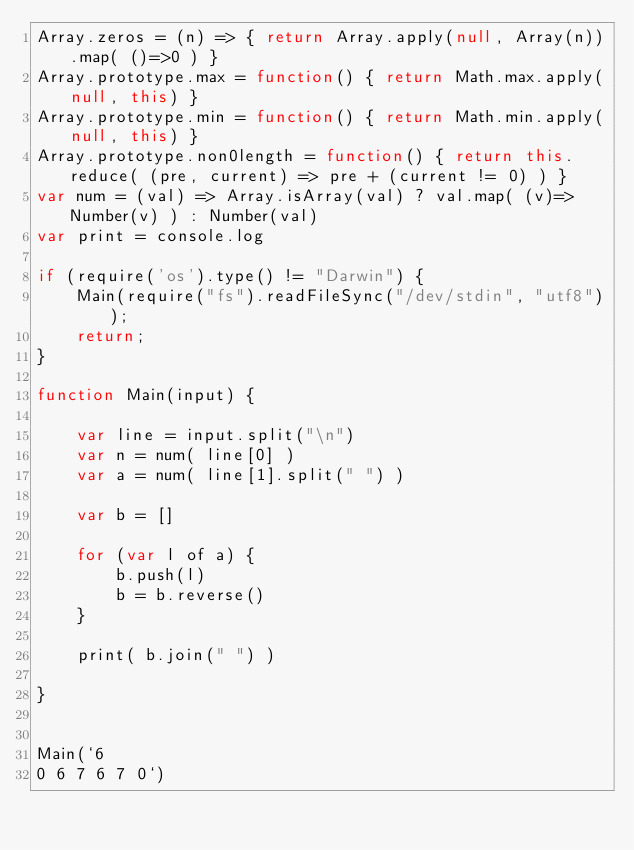<code> <loc_0><loc_0><loc_500><loc_500><_JavaScript_>Array.zeros = (n) => { return Array.apply(null, Array(n)).map( ()=>0 ) }
Array.prototype.max = function() { return Math.max.apply(null, this) }
Array.prototype.min = function() { return Math.min.apply(null, this) }
Array.prototype.non0length = function() { return this.reduce( (pre, current) => pre + (current != 0) ) }
var num = (val) => Array.isArray(val) ? val.map( (v)=>Number(v) ) : Number(val)
var print = console.log

if (require('os').type() != "Darwin") {
	Main(require("fs").readFileSync("/dev/stdin", "utf8"));
	return;
}

function Main(input) {

	var line = input.split("\n")
	var n = num( line[0] )
	var a = num( line[1].split(" ") )

	var b = []

	for (var l of a) {
		b.push(l)
		b = b.reverse()
	}

	print( b.join(" ") )

}


Main(`6
0 6 7 6 7 0`)
</code> 